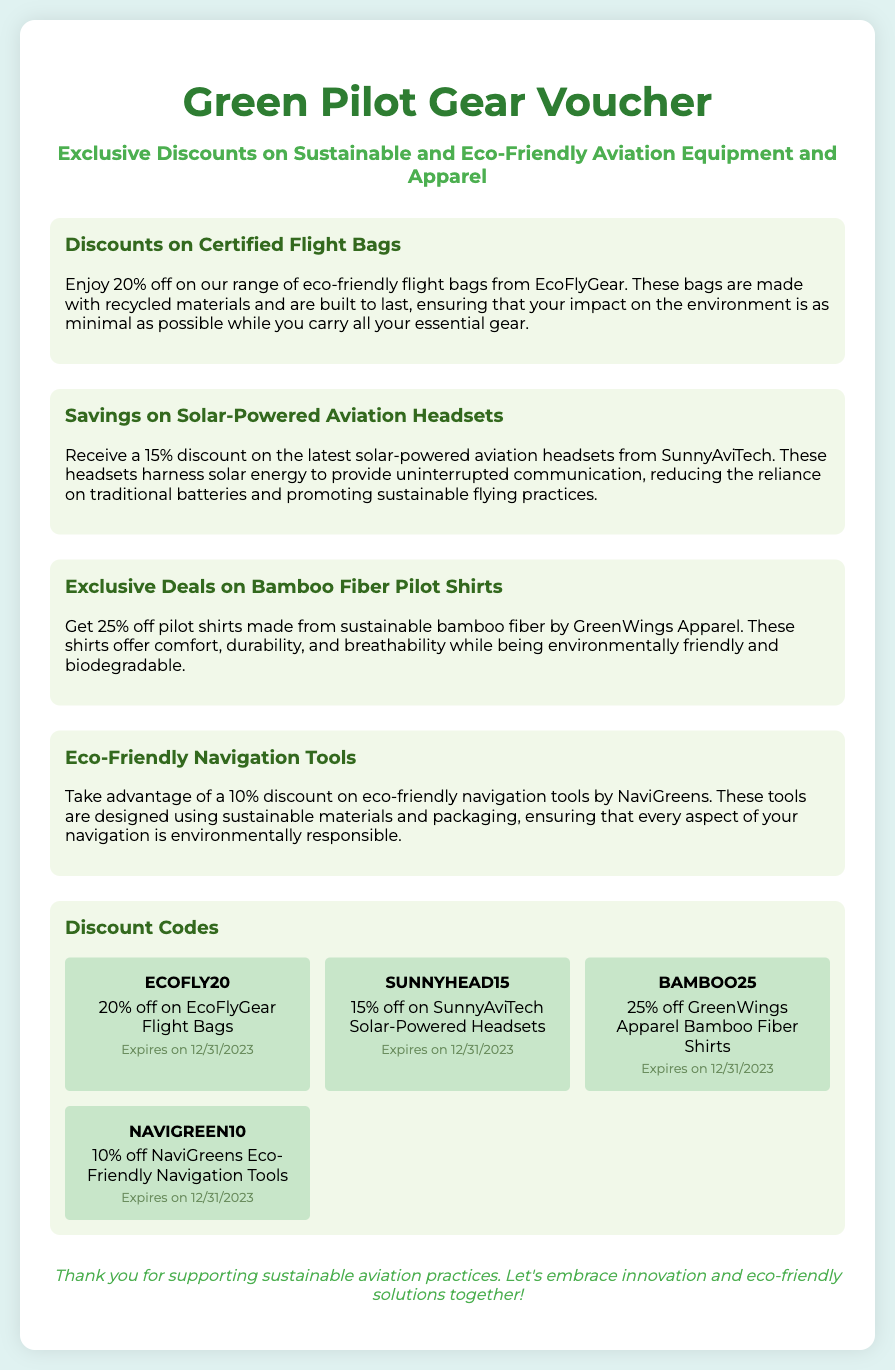What is the discount on EcoFlyGear flight bags? The document states that there is a 20% discount on EcoFlyGear flight bags.
Answer: 20% What material are the bamboo fiber pilot shirts made from? The pilot shirts are made from sustainable bamboo fiber.
Answer: Bamboo fiber What discount is offered on solar-powered aviation headsets? The document mentions a 15% discount on solar-powered aviation headsets.
Answer: 15% What is the expiry date for all discount codes? The expiry date for all discount codes listed in the document is 12/31/2023.
Answer: 12/31/2023 Which company offers eco-friendly navigation tools? Eco-friendly navigation tools are offered by NaviGreens.
Answer: NaviGreens What percentage discount is given on bamboo fiber shirts? The document specifies a 25% discount for bamboo fiber shirts.
Answer: 25% What color is used for the voucher header? The color used for the voucher header is #2e7d32.
Answer: #2e7d32 What type of discount is applicable for tools from NaviGreens? The discount applicable for tools from NaviGreens is 10%.
Answer: 10% What message is conveyed in the footer of the voucher? The footer conveys a message of appreciation for supporting sustainable aviation practices.
Answer: Thank you for supporting sustainable aviation practices 